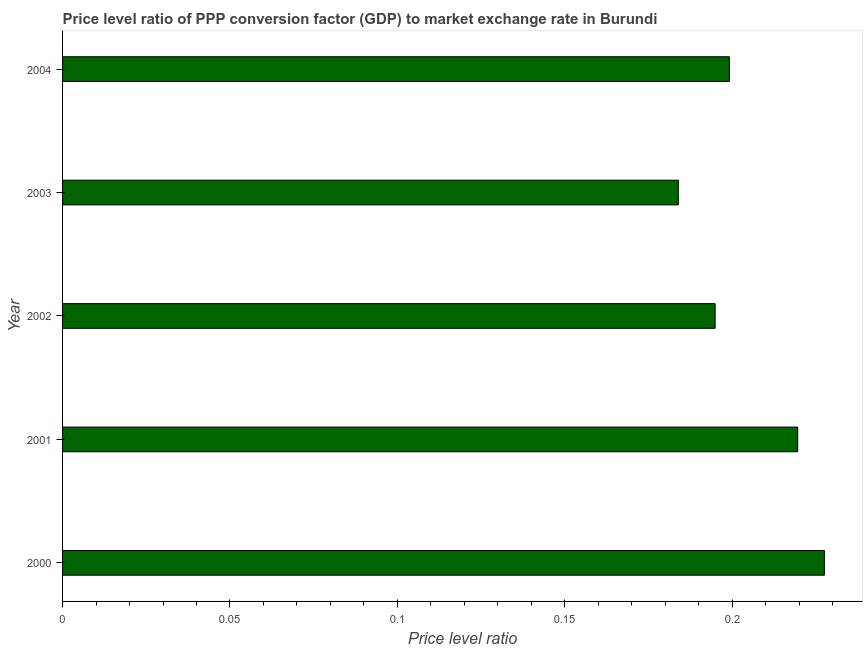Does the graph contain any zero values?
Keep it short and to the point. No. Does the graph contain grids?
Offer a very short reply. No. What is the title of the graph?
Your answer should be very brief. Price level ratio of PPP conversion factor (GDP) to market exchange rate in Burundi. What is the label or title of the X-axis?
Ensure brevity in your answer.  Price level ratio. What is the price level ratio in 2001?
Offer a very short reply. 0.22. Across all years, what is the maximum price level ratio?
Your response must be concise. 0.23. Across all years, what is the minimum price level ratio?
Offer a terse response. 0.18. In which year was the price level ratio maximum?
Give a very brief answer. 2000. What is the sum of the price level ratio?
Give a very brief answer. 1.03. What is the difference between the price level ratio in 2000 and 2002?
Provide a succinct answer. 0.03. What is the average price level ratio per year?
Provide a succinct answer. 0.2. What is the median price level ratio?
Your answer should be very brief. 0.2. Do a majority of the years between 2000 and 2004 (inclusive) have price level ratio greater than 0.22 ?
Give a very brief answer. No. What is the ratio of the price level ratio in 2001 to that in 2004?
Your response must be concise. 1.1. Is the price level ratio in 2001 less than that in 2004?
Provide a short and direct response. No. Is the difference between the price level ratio in 2000 and 2002 greater than the difference between any two years?
Keep it short and to the point. No. What is the difference between the highest and the second highest price level ratio?
Your response must be concise. 0.01. Is the sum of the price level ratio in 2001 and 2003 greater than the maximum price level ratio across all years?
Keep it short and to the point. Yes. What is the difference between the highest and the lowest price level ratio?
Your response must be concise. 0.04. In how many years, is the price level ratio greater than the average price level ratio taken over all years?
Ensure brevity in your answer.  2. How many bars are there?
Provide a succinct answer. 5. Are all the bars in the graph horizontal?
Ensure brevity in your answer.  Yes. Are the values on the major ticks of X-axis written in scientific E-notation?
Your response must be concise. No. What is the Price level ratio in 2000?
Offer a very short reply. 0.23. What is the Price level ratio in 2001?
Offer a very short reply. 0.22. What is the Price level ratio in 2002?
Give a very brief answer. 0.19. What is the Price level ratio of 2003?
Offer a very short reply. 0.18. What is the Price level ratio in 2004?
Your response must be concise. 0.2. What is the difference between the Price level ratio in 2000 and 2001?
Give a very brief answer. 0.01. What is the difference between the Price level ratio in 2000 and 2002?
Make the answer very short. 0.03. What is the difference between the Price level ratio in 2000 and 2003?
Provide a succinct answer. 0.04. What is the difference between the Price level ratio in 2000 and 2004?
Give a very brief answer. 0.03. What is the difference between the Price level ratio in 2001 and 2002?
Offer a very short reply. 0.02. What is the difference between the Price level ratio in 2001 and 2003?
Make the answer very short. 0.04. What is the difference between the Price level ratio in 2001 and 2004?
Offer a terse response. 0.02. What is the difference between the Price level ratio in 2002 and 2003?
Your answer should be very brief. 0.01. What is the difference between the Price level ratio in 2002 and 2004?
Your response must be concise. -0. What is the difference between the Price level ratio in 2003 and 2004?
Keep it short and to the point. -0.02. What is the ratio of the Price level ratio in 2000 to that in 2001?
Keep it short and to the point. 1.04. What is the ratio of the Price level ratio in 2000 to that in 2002?
Make the answer very short. 1.17. What is the ratio of the Price level ratio in 2000 to that in 2003?
Provide a succinct answer. 1.24. What is the ratio of the Price level ratio in 2000 to that in 2004?
Your answer should be very brief. 1.14. What is the ratio of the Price level ratio in 2001 to that in 2002?
Provide a short and direct response. 1.13. What is the ratio of the Price level ratio in 2001 to that in 2003?
Your response must be concise. 1.19. What is the ratio of the Price level ratio in 2001 to that in 2004?
Ensure brevity in your answer.  1.1. What is the ratio of the Price level ratio in 2002 to that in 2003?
Offer a very short reply. 1.06. What is the ratio of the Price level ratio in 2003 to that in 2004?
Offer a very short reply. 0.92. 